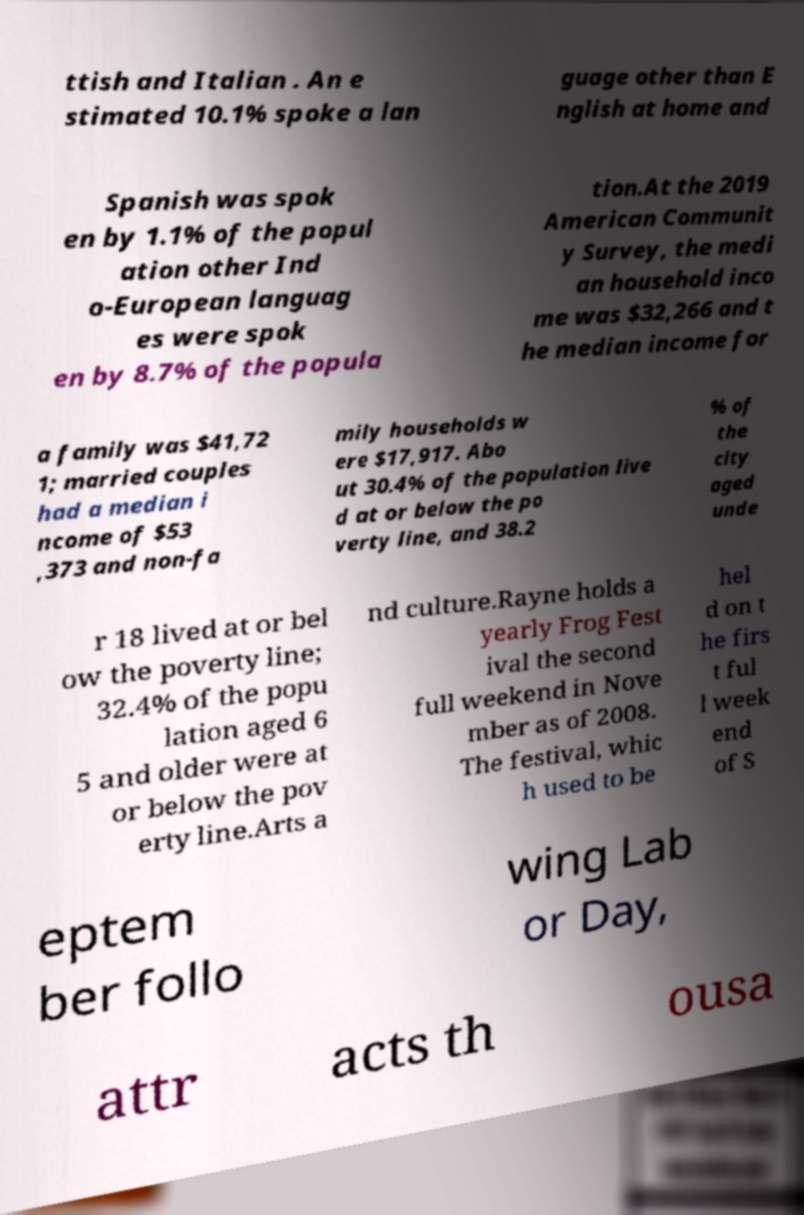Could you extract and type out the text from this image? ttish and Italian . An e stimated 10.1% spoke a lan guage other than E nglish at home and Spanish was spok en by 1.1% of the popul ation other Ind o-European languag es were spok en by 8.7% of the popula tion.At the 2019 American Communit y Survey, the medi an household inco me was $32,266 and t he median income for a family was $41,72 1; married couples had a median i ncome of $53 ,373 and non-fa mily households w ere $17,917. Abo ut 30.4% of the population live d at or below the po verty line, and 38.2 % of the city aged unde r 18 lived at or bel ow the poverty line; 32.4% of the popu lation aged 6 5 and older were at or below the pov erty line.Arts a nd culture.Rayne holds a yearly Frog Fest ival the second full weekend in Nove mber as of 2008. The festival, whic h used to be hel d on t he firs t ful l week end of S eptem ber follo wing Lab or Day, attr acts th ousa 